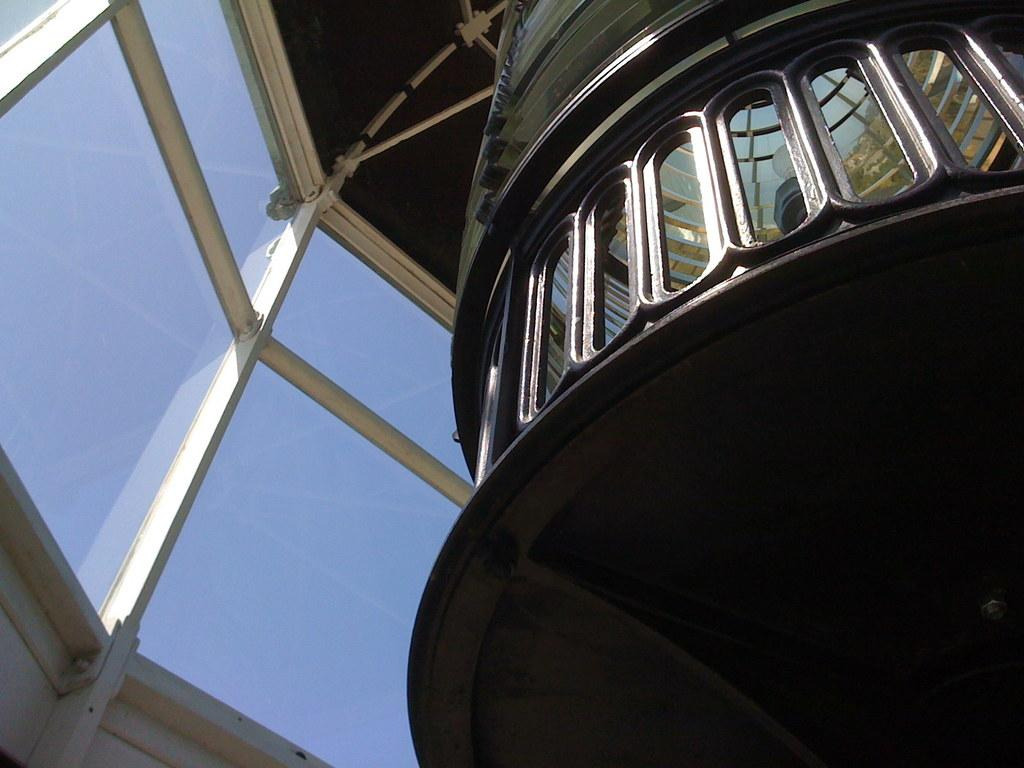What type of structure is present in the image? There is a building in the image. What feature can be observed on the building? The building has glass windows. What type of spark can be seen coming from the building in the image? There is no spark present in the image; the building has glass windows, but no indication of a spark. 